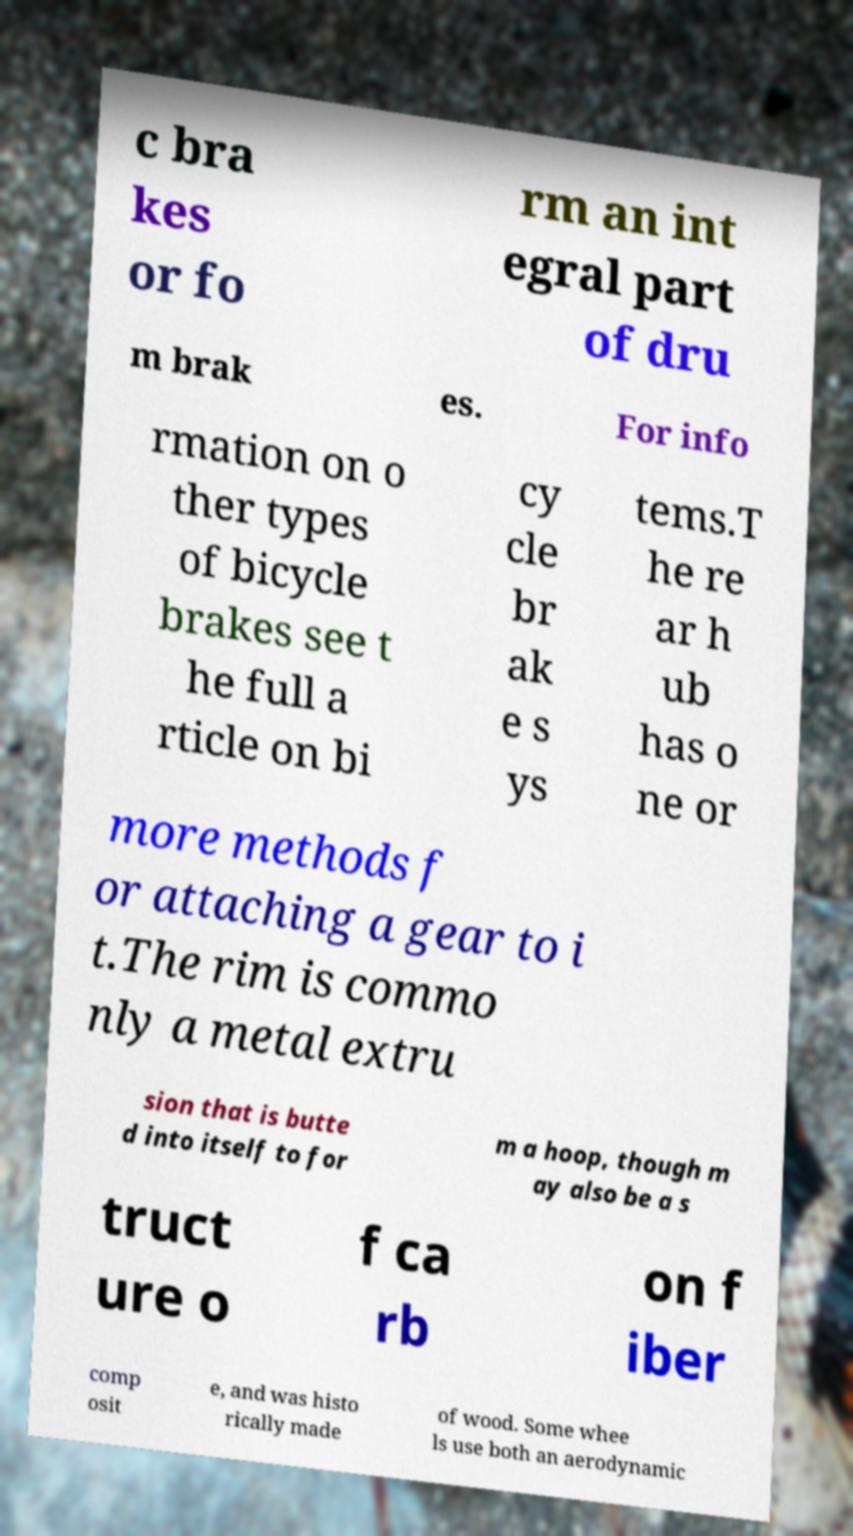Can you read and provide the text displayed in the image?This photo seems to have some interesting text. Can you extract and type it out for me? c bra kes or fo rm an int egral part of dru m brak es. For info rmation on o ther types of bicycle brakes see t he full a rticle on bi cy cle br ak e s ys tems.T he re ar h ub has o ne or more methods f or attaching a gear to i t.The rim is commo nly a metal extru sion that is butte d into itself to for m a hoop, though m ay also be a s truct ure o f ca rb on f iber comp osit e, and was histo rically made of wood. Some whee ls use both an aerodynamic 